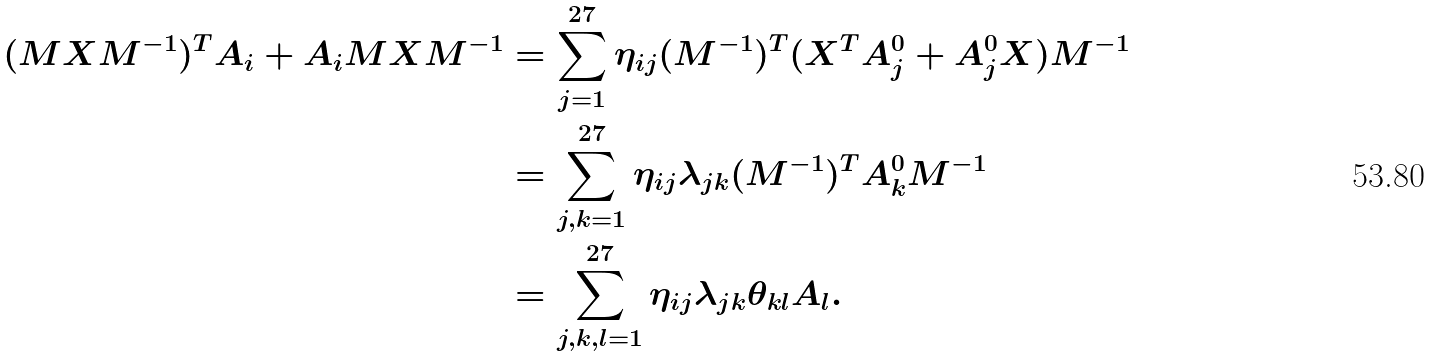Convert formula to latex. <formula><loc_0><loc_0><loc_500><loc_500>( M X M ^ { - 1 } ) ^ { T } A _ { i } + A _ { i } M X M ^ { - 1 } & = \sum _ { j = 1 } ^ { 2 7 } \eta _ { i j } ( M ^ { - 1 } ) ^ { T } ( X ^ { T } A _ { j } ^ { 0 } + A _ { j } ^ { 0 } X ) M ^ { - 1 } \\ & = \sum _ { j , k = 1 } ^ { 2 7 } \eta _ { i j } \lambda _ { j k } ( M ^ { - 1 } ) ^ { T } A _ { k } ^ { 0 } M ^ { - 1 } \\ & = \sum _ { j , k , l = 1 } ^ { 2 7 } \eta _ { i j } \lambda _ { j k } \theta _ { k l } A _ { l } .</formula> 